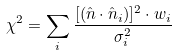Convert formula to latex. <formula><loc_0><loc_0><loc_500><loc_500>\chi ^ { 2 } = \sum _ { i } \frac { [ ( \hat { n } \cdot \hat { n } _ { i } ) ] ^ { 2 } \cdot w _ { i } } { \sigma _ { i } ^ { 2 } }</formula> 